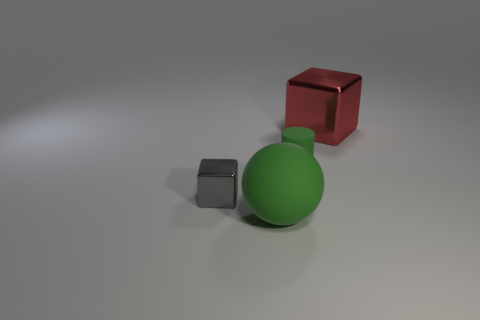Add 3 big purple matte cylinders. How many objects exist? 7 Subtract all balls. How many objects are left? 3 Subtract all red cubes. How many cubes are left? 1 Subtract all blue balls. How many red cubes are left? 1 Subtract 0 blue cubes. How many objects are left? 4 Subtract all red spheres. Subtract all green blocks. How many spheres are left? 1 Subtract all red metal things. Subtract all tiny green cylinders. How many objects are left? 2 Add 4 small rubber cylinders. How many small rubber cylinders are left? 5 Add 2 big green metallic spheres. How many big green metallic spheres exist? 2 